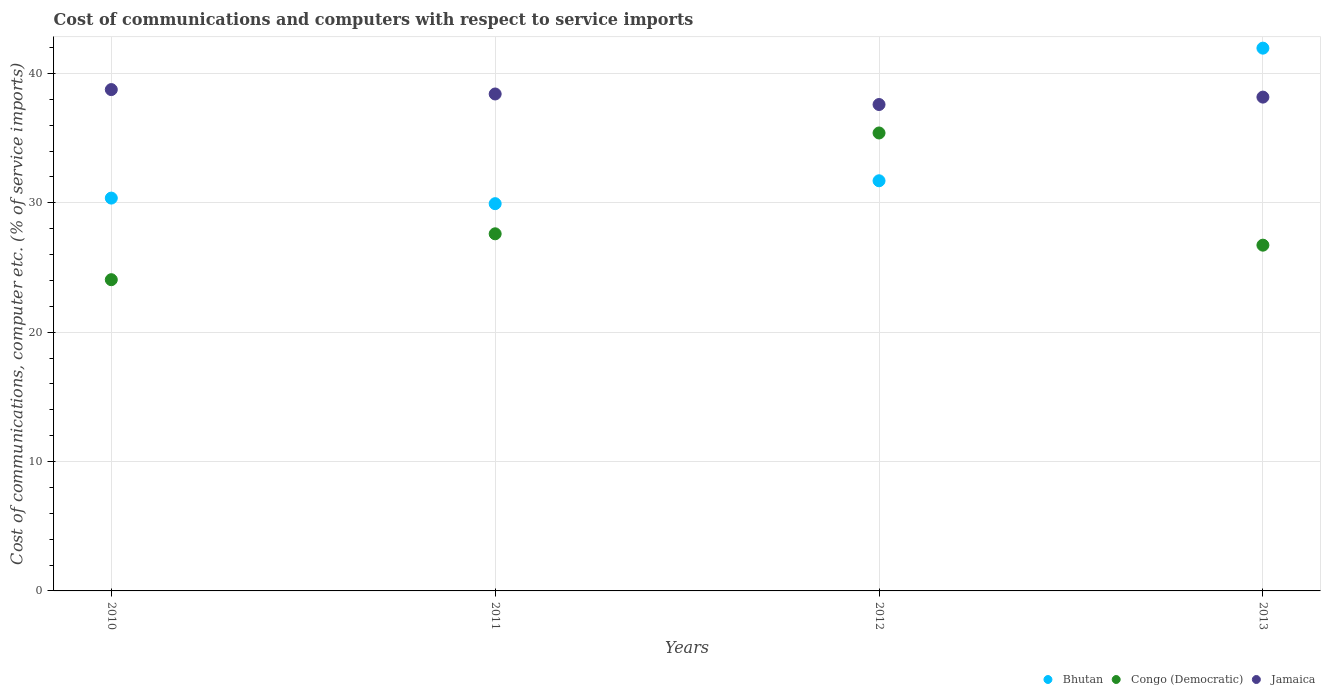How many different coloured dotlines are there?
Offer a very short reply. 3. What is the cost of communications and computers in Jamaica in 2013?
Provide a short and direct response. 38.17. Across all years, what is the maximum cost of communications and computers in Congo (Democratic)?
Make the answer very short. 35.4. Across all years, what is the minimum cost of communications and computers in Jamaica?
Offer a terse response. 37.6. In which year was the cost of communications and computers in Jamaica maximum?
Offer a very short reply. 2010. In which year was the cost of communications and computers in Jamaica minimum?
Give a very brief answer. 2012. What is the total cost of communications and computers in Bhutan in the graph?
Provide a short and direct response. 133.96. What is the difference between the cost of communications and computers in Congo (Democratic) in 2010 and that in 2012?
Provide a succinct answer. -11.34. What is the difference between the cost of communications and computers in Jamaica in 2011 and the cost of communications and computers in Bhutan in 2012?
Offer a very short reply. 6.71. What is the average cost of communications and computers in Bhutan per year?
Your response must be concise. 33.49. In the year 2012, what is the difference between the cost of communications and computers in Jamaica and cost of communications and computers in Congo (Democratic)?
Offer a terse response. 2.2. In how many years, is the cost of communications and computers in Congo (Democratic) greater than 14 %?
Ensure brevity in your answer.  4. What is the ratio of the cost of communications and computers in Jamaica in 2011 to that in 2013?
Ensure brevity in your answer.  1.01. Is the cost of communications and computers in Bhutan in 2011 less than that in 2013?
Your response must be concise. Yes. Is the difference between the cost of communications and computers in Jamaica in 2011 and 2013 greater than the difference between the cost of communications and computers in Congo (Democratic) in 2011 and 2013?
Provide a succinct answer. No. What is the difference between the highest and the second highest cost of communications and computers in Jamaica?
Keep it short and to the point. 0.34. What is the difference between the highest and the lowest cost of communications and computers in Congo (Democratic)?
Make the answer very short. 11.34. Is the cost of communications and computers in Bhutan strictly greater than the cost of communications and computers in Congo (Democratic) over the years?
Offer a terse response. No. How many dotlines are there?
Give a very brief answer. 3. How many years are there in the graph?
Give a very brief answer. 4. What is the difference between two consecutive major ticks on the Y-axis?
Your answer should be compact. 10. Are the values on the major ticks of Y-axis written in scientific E-notation?
Your response must be concise. No. Does the graph contain grids?
Give a very brief answer. Yes. Where does the legend appear in the graph?
Offer a very short reply. Bottom right. What is the title of the graph?
Offer a terse response. Cost of communications and computers with respect to service imports. What is the label or title of the X-axis?
Your answer should be compact. Years. What is the label or title of the Y-axis?
Keep it short and to the point. Cost of communications, computer etc. (% of service imports). What is the Cost of communications, computer etc. (% of service imports) of Bhutan in 2010?
Your answer should be very brief. 30.37. What is the Cost of communications, computer etc. (% of service imports) in Congo (Democratic) in 2010?
Offer a very short reply. 24.06. What is the Cost of communications, computer etc. (% of service imports) of Jamaica in 2010?
Your answer should be compact. 38.75. What is the Cost of communications, computer etc. (% of service imports) in Bhutan in 2011?
Keep it short and to the point. 29.94. What is the Cost of communications, computer etc. (% of service imports) in Congo (Democratic) in 2011?
Provide a short and direct response. 27.61. What is the Cost of communications, computer etc. (% of service imports) in Jamaica in 2011?
Offer a very short reply. 38.41. What is the Cost of communications, computer etc. (% of service imports) of Bhutan in 2012?
Provide a short and direct response. 31.7. What is the Cost of communications, computer etc. (% of service imports) of Congo (Democratic) in 2012?
Ensure brevity in your answer.  35.4. What is the Cost of communications, computer etc. (% of service imports) of Jamaica in 2012?
Give a very brief answer. 37.6. What is the Cost of communications, computer etc. (% of service imports) in Bhutan in 2013?
Your response must be concise. 41.96. What is the Cost of communications, computer etc. (% of service imports) of Congo (Democratic) in 2013?
Provide a succinct answer. 26.73. What is the Cost of communications, computer etc. (% of service imports) of Jamaica in 2013?
Make the answer very short. 38.17. Across all years, what is the maximum Cost of communications, computer etc. (% of service imports) in Bhutan?
Your answer should be compact. 41.96. Across all years, what is the maximum Cost of communications, computer etc. (% of service imports) in Congo (Democratic)?
Your answer should be compact. 35.4. Across all years, what is the maximum Cost of communications, computer etc. (% of service imports) in Jamaica?
Provide a short and direct response. 38.75. Across all years, what is the minimum Cost of communications, computer etc. (% of service imports) of Bhutan?
Ensure brevity in your answer.  29.94. Across all years, what is the minimum Cost of communications, computer etc. (% of service imports) of Congo (Democratic)?
Offer a very short reply. 24.06. Across all years, what is the minimum Cost of communications, computer etc. (% of service imports) in Jamaica?
Give a very brief answer. 37.6. What is the total Cost of communications, computer etc. (% of service imports) of Bhutan in the graph?
Ensure brevity in your answer.  133.96. What is the total Cost of communications, computer etc. (% of service imports) in Congo (Democratic) in the graph?
Provide a succinct answer. 113.79. What is the total Cost of communications, computer etc. (% of service imports) in Jamaica in the graph?
Give a very brief answer. 152.94. What is the difference between the Cost of communications, computer etc. (% of service imports) of Bhutan in 2010 and that in 2011?
Your answer should be very brief. 0.43. What is the difference between the Cost of communications, computer etc. (% of service imports) of Congo (Democratic) in 2010 and that in 2011?
Your answer should be compact. -3.55. What is the difference between the Cost of communications, computer etc. (% of service imports) of Jamaica in 2010 and that in 2011?
Provide a succinct answer. 0.34. What is the difference between the Cost of communications, computer etc. (% of service imports) in Bhutan in 2010 and that in 2012?
Provide a succinct answer. -1.34. What is the difference between the Cost of communications, computer etc. (% of service imports) of Congo (Democratic) in 2010 and that in 2012?
Keep it short and to the point. -11.34. What is the difference between the Cost of communications, computer etc. (% of service imports) in Jamaica in 2010 and that in 2012?
Provide a succinct answer. 1.15. What is the difference between the Cost of communications, computer etc. (% of service imports) of Bhutan in 2010 and that in 2013?
Your answer should be compact. -11.59. What is the difference between the Cost of communications, computer etc. (% of service imports) in Congo (Democratic) in 2010 and that in 2013?
Offer a very short reply. -2.67. What is the difference between the Cost of communications, computer etc. (% of service imports) in Jamaica in 2010 and that in 2013?
Offer a very short reply. 0.58. What is the difference between the Cost of communications, computer etc. (% of service imports) in Bhutan in 2011 and that in 2012?
Ensure brevity in your answer.  -1.77. What is the difference between the Cost of communications, computer etc. (% of service imports) in Congo (Democratic) in 2011 and that in 2012?
Your response must be concise. -7.79. What is the difference between the Cost of communications, computer etc. (% of service imports) of Jamaica in 2011 and that in 2012?
Give a very brief answer. 0.81. What is the difference between the Cost of communications, computer etc. (% of service imports) in Bhutan in 2011 and that in 2013?
Your response must be concise. -12.02. What is the difference between the Cost of communications, computer etc. (% of service imports) of Congo (Democratic) in 2011 and that in 2013?
Offer a terse response. 0.88. What is the difference between the Cost of communications, computer etc. (% of service imports) in Jamaica in 2011 and that in 2013?
Provide a short and direct response. 0.24. What is the difference between the Cost of communications, computer etc. (% of service imports) of Bhutan in 2012 and that in 2013?
Your answer should be very brief. -10.25. What is the difference between the Cost of communications, computer etc. (% of service imports) in Congo (Democratic) in 2012 and that in 2013?
Provide a succinct answer. 8.67. What is the difference between the Cost of communications, computer etc. (% of service imports) of Jamaica in 2012 and that in 2013?
Your answer should be compact. -0.57. What is the difference between the Cost of communications, computer etc. (% of service imports) of Bhutan in 2010 and the Cost of communications, computer etc. (% of service imports) of Congo (Democratic) in 2011?
Provide a succinct answer. 2.76. What is the difference between the Cost of communications, computer etc. (% of service imports) in Bhutan in 2010 and the Cost of communications, computer etc. (% of service imports) in Jamaica in 2011?
Keep it short and to the point. -8.05. What is the difference between the Cost of communications, computer etc. (% of service imports) of Congo (Democratic) in 2010 and the Cost of communications, computer etc. (% of service imports) of Jamaica in 2011?
Make the answer very short. -14.36. What is the difference between the Cost of communications, computer etc. (% of service imports) of Bhutan in 2010 and the Cost of communications, computer etc. (% of service imports) of Congo (Democratic) in 2012?
Your answer should be compact. -5.03. What is the difference between the Cost of communications, computer etc. (% of service imports) of Bhutan in 2010 and the Cost of communications, computer etc. (% of service imports) of Jamaica in 2012?
Keep it short and to the point. -7.23. What is the difference between the Cost of communications, computer etc. (% of service imports) of Congo (Democratic) in 2010 and the Cost of communications, computer etc. (% of service imports) of Jamaica in 2012?
Keep it short and to the point. -13.54. What is the difference between the Cost of communications, computer etc. (% of service imports) of Bhutan in 2010 and the Cost of communications, computer etc. (% of service imports) of Congo (Democratic) in 2013?
Make the answer very short. 3.64. What is the difference between the Cost of communications, computer etc. (% of service imports) of Bhutan in 2010 and the Cost of communications, computer etc. (% of service imports) of Jamaica in 2013?
Your answer should be compact. -7.81. What is the difference between the Cost of communications, computer etc. (% of service imports) of Congo (Democratic) in 2010 and the Cost of communications, computer etc. (% of service imports) of Jamaica in 2013?
Provide a short and direct response. -14.11. What is the difference between the Cost of communications, computer etc. (% of service imports) of Bhutan in 2011 and the Cost of communications, computer etc. (% of service imports) of Congo (Democratic) in 2012?
Your response must be concise. -5.46. What is the difference between the Cost of communications, computer etc. (% of service imports) in Bhutan in 2011 and the Cost of communications, computer etc. (% of service imports) in Jamaica in 2012?
Your response must be concise. -7.66. What is the difference between the Cost of communications, computer etc. (% of service imports) of Congo (Democratic) in 2011 and the Cost of communications, computer etc. (% of service imports) of Jamaica in 2012?
Provide a short and direct response. -9.99. What is the difference between the Cost of communications, computer etc. (% of service imports) of Bhutan in 2011 and the Cost of communications, computer etc. (% of service imports) of Congo (Democratic) in 2013?
Offer a terse response. 3.21. What is the difference between the Cost of communications, computer etc. (% of service imports) of Bhutan in 2011 and the Cost of communications, computer etc. (% of service imports) of Jamaica in 2013?
Your answer should be very brief. -8.24. What is the difference between the Cost of communications, computer etc. (% of service imports) of Congo (Democratic) in 2011 and the Cost of communications, computer etc. (% of service imports) of Jamaica in 2013?
Your answer should be compact. -10.57. What is the difference between the Cost of communications, computer etc. (% of service imports) in Bhutan in 2012 and the Cost of communications, computer etc. (% of service imports) in Congo (Democratic) in 2013?
Offer a very short reply. 4.98. What is the difference between the Cost of communications, computer etc. (% of service imports) of Bhutan in 2012 and the Cost of communications, computer etc. (% of service imports) of Jamaica in 2013?
Provide a short and direct response. -6.47. What is the difference between the Cost of communications, computer etc. (% of service imports) of Congo (Democratic) in 2012 and the Cost of communications, computer etc. (% of service imports) of Jamaica in 2013?
Keep it short and to the point. -2.77. What is the average Cost of communications, computer etc. (% of service imports) of Bhutan per year?
Provide a succinct answer. 33.49. What is the average Cost of communications, computer etc. (% of service imports) of Congo (Democratic) per year?
Your answer should be compact. 28.45. What is the average Cost of communications, computer etc. (% of service imports) in Jamaica per year?
Offer a very short reply. 38.23. In the year 2010, what is the difference between the Cost of communications, computer etc. (% of service imports) in Bhutan and Cost of communications, computer etc. (% of service imports) in Congo (Democratic)?
Offer a very short reply. 6.31. In the year 2010, what is the difference between the Cost of communications, computer etc. (% of service imports) in Bhutan and Cost of communications, computer etc. (% of service imports) in Jamaica?
Your answer should be very brief. -8.39. In the year 2010, what is the difference between the Cost of communications, computer etc. (% of service imports) in Congo (Democratic) and Cost of communications, computer etc. (% of service imports) in Jamaica?
Ensure brevity in your answer.  -14.7. In the year 2011, what is the difference between the Cost of communications, computer etc. (% of service imports) in Bhutan and Cost of communications, computer etc. (% of service imports) in Congo (Democratic)?
Keep it short and to the point. 2.33. In the year 2011, what is the difference between the Cost of communications, computer etc. (% of service imports) in Bhutan and Cost of communications, computer etc. (% of service imports) in Jamaica?
Make the answer very short. -8.48. In the year 2011, what is the difference between the Cost of communications, computer etc. (% of service imports) in Congo (Democratic) and Cost of communications, computer etc. (% of service imports) in Jamaica?
Keep it short and to the point. -10.81. In the year 2012, what is the difference between the Cost of communications, computer etc. (% of service imports) in Bhutan and Cost of communications, computer etc. (% of service imports) in Congo (Democratic)?
Your answer should be very brief. -3.69. In the year 2012, what is the difference between the Cost of communications, computer etc. (% of service imports) in Bhutan and Cost of communications, computer etc. (% of service imports) in Jamaica?
Provide a succinct answer. -5.89. In the year 2012, what is the difference between the Cost of communications, computer etc. (% of service imports) of Congo (Democratic) and Cost of communications, computer etc. (% of service imports) of Jamaica?
Offer a terse response. -2.2. In the year 2013, what is the difference between the Cost of communications, computer etc. (% of service imports) of Bhutan and Cost of communications, computer etc. (% of service imports) of Congo (Democratic)?
Make the answer very short. 15.23. In the year 2013, what is the difference between the Cost of communications, computer etc. (% of service imports) in Bhutan and Cost of communications, computer etc. (% of service imports) in Jamaica?
Make the answer very short. 3.78. In the year 2013, what is the difference between the Cost of communications, computer etc. (% of service imports) in Congo (Democratic) and Cost of communications, computer etc. (% of service imports) in Jamaica?
Your answer should be very brief. -11.44. What is the ratio of the Cost of communications, computer etc. (% of service imports) in Bhutan in 2010 to that in 2011?
Your answer should be very brief. 1.01. What is the ratio of the Cost of communications, computer etc. (% of service imports) of Congo (Democratic) in 2010 to that in 2011?
Ensure brevity in your answer.  0.87. What is the ratio of the Cost of communications, computer etc. (% of service imports) in Jamaica in 2010 to that in 2011?
Make the answer very short. 1.01. What is the ratio of the Cost of communications, computer etc. (% of service imports) in Bhutan in 2010 to that in 2012?
Your response must be concise. 0.96. What is the ratio of the Cost of communications, computer etc. (% of service imports) in Congo (Democratic) in 2010 to that in 2012?
Your answer should be very brief. 0.68. What is the ratio of the Cost of communications, computer etc. (% of service imports) of Jamaica in 2010 to that in 2012?
Provide a short and direct response. 1.03. What is the ratio of the Cost of communications, computer etc. (% of service imports) in Bhutan in 2010 to that in 2013?
Offer a very short reply. 0.72. What is the ratio of the Cost of communications, computer etc. (% of service imports) in Congo (Democratic) in 2010 to that in 2013?
Provide a short and direct response. 0.9. What is the ratio of the Cost of communications, computer etc. (% of service imports) of Jamaica in 2010 to that in 2013?
Offer a very short reply. 1.02. What is the ratio of the Cost of communications, computer etc. (% of service imports) in Bhutan in 2011 to that in 2012?
Your answer should be very brief. 0.94. What is the ratio of the Cost of communications, computer etc. (% of service imports) in Congo (Democratic) in 2011 to that in 2012?
Keep it short and to the point. 0.78. What is the ratio of the Cost of communications, computer etc. (% of service imports) in Jamaica in 2011 to that in 2012?
Keep it short and to the point. 1.02. What is the ratio of the Cost of communications, computer etc. (% of service imports) of Bhutan in 2011 to that in 2013?
Offer a terse response. 0.71. What is the ratio of the Cost of communications, computer etc. (% of service imports) of Congo (Democratic) in 2011 to that in 2013?
Make the answer very short. 1.03. What is the ratio of the Cost of communications, computer etc. (% of service imports) in Jamaica in 2011 to that in 2013?
Offer a very short reply. 1.01. What is the ratio of the Cost of communications, computer etc. (% of service imports) of Bhutan in 2012 to that in 2013?
Provide a short and direct response. 0.76. What is the ratio of the Cost of communications, computer etc. (% of service imports) of Congo (Democratic) in 2012 to that in 2013?
Give a very brief answer. 1.32. What is the ratio of the Cost of communications, computer etc. (% of service imports) of Jamaica in 2012 to that in 2013?
Offer a very short reply. 0.98. What is the difference between the highest and the second highest Cost of communications, computer etc. (% of service imports) of Bhutan?
Your answer should be compact. 10.25. What is the difference between the highest and the second highest Cost of communications, computer etc. (% of service imports) of Congo (Democratic)?
Offer a very short reply. 7.79. What is the difference between the highest and the second highest Cost of communications, computer etc. (% of service imports) of Jamaica?
Make the answer very short. 0.34. What is the difference between the highest and the lowest Cost of communications, computer etc. (% of service imports) in Bhutan?
Offer a terse response. 12.02. What is the difference between the highest and the lowest Cost of communications, computer etc. (% of service imports) in Congo (Democratic)?
Provide a succinct answer. 11.34. What is the difference between the highest and the lowest Cost of communications, computer etc. (% of service imports) of Jamaica?
Your answer should be very brief. 1.15. 